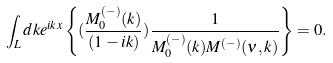Convert formula to latex. <formula><loc_0><loc_0><loc_500><loc_500>\int _ { L } d k e ^ { i k x } \left \{ ( \frac { M _ { 0 } ^ { ( - ) } ( k ) } { ( 1 - i k ) } ) \frac { 1 } { M _ { 0 } ^ { ( - ) } ( k ) M ^ { ( - ) } ( \nu , k ) } \right \} = 0 .</formula> 